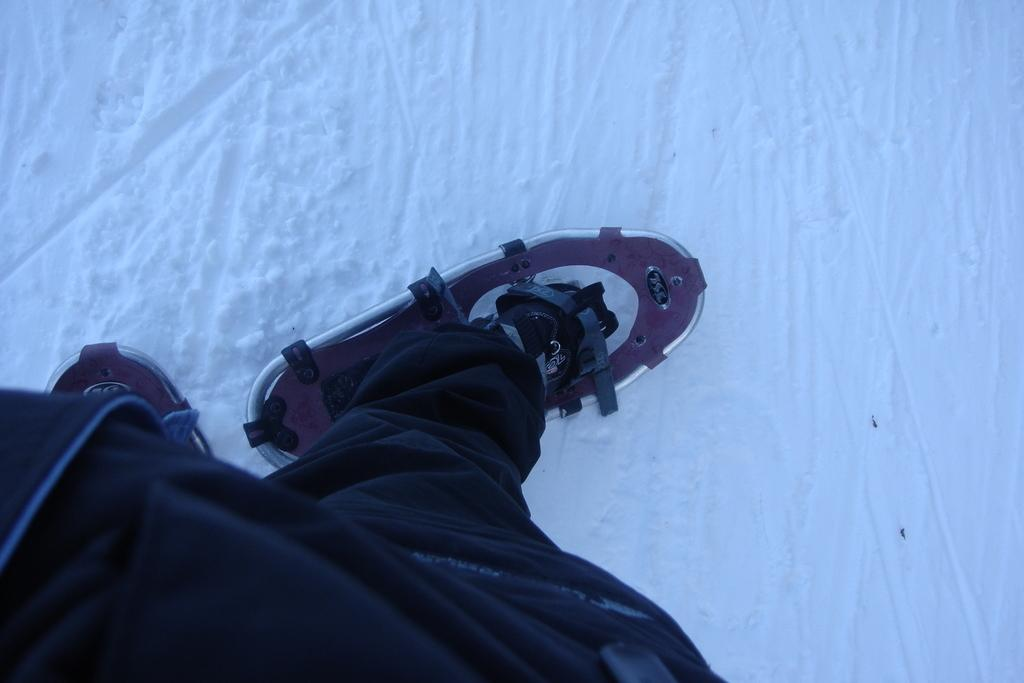What is the surface on which the image is taken? The image is taken on ice. Can you describe the person in the image? There is a person in the image, and they are skating on the ice. What is the person wearing in the image? The person is wearing a black dress. What type of road sign can be seen in the image? There is no road sign present in the image, as it is taken on ice and not on a road. 